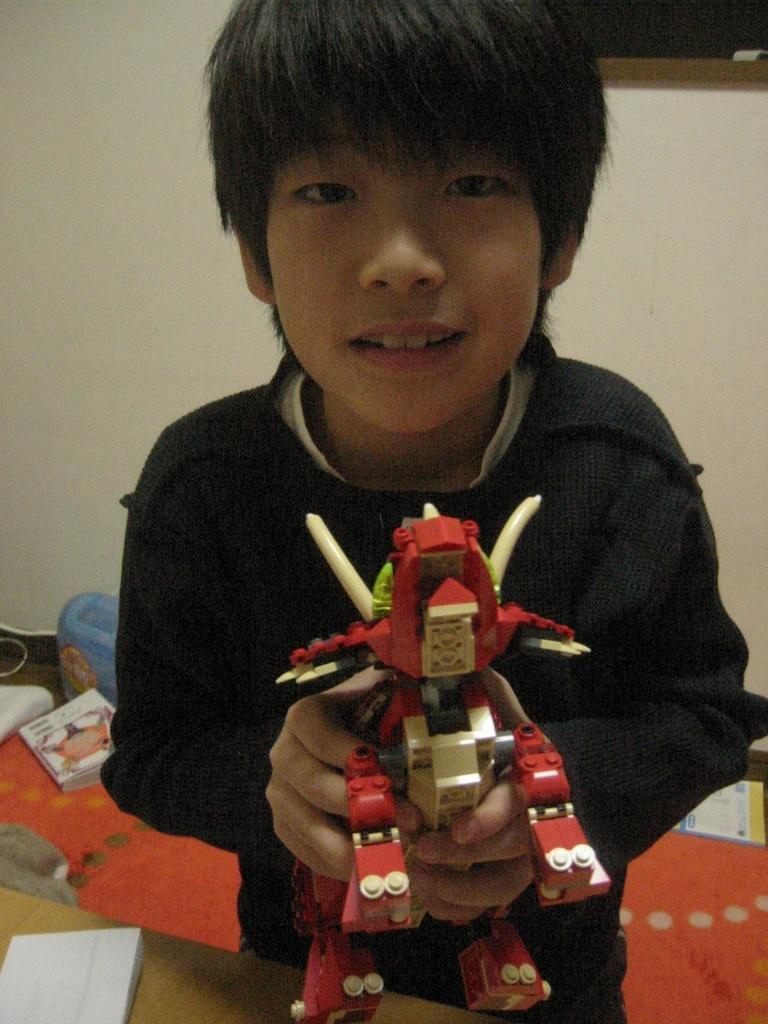Describe this image in one or two sentences. In this image I can see a boy wearing a black color t-shirt and holding a remote , standing on the red color carpet , on the carpet I can see book and in the background I can see the wall. 